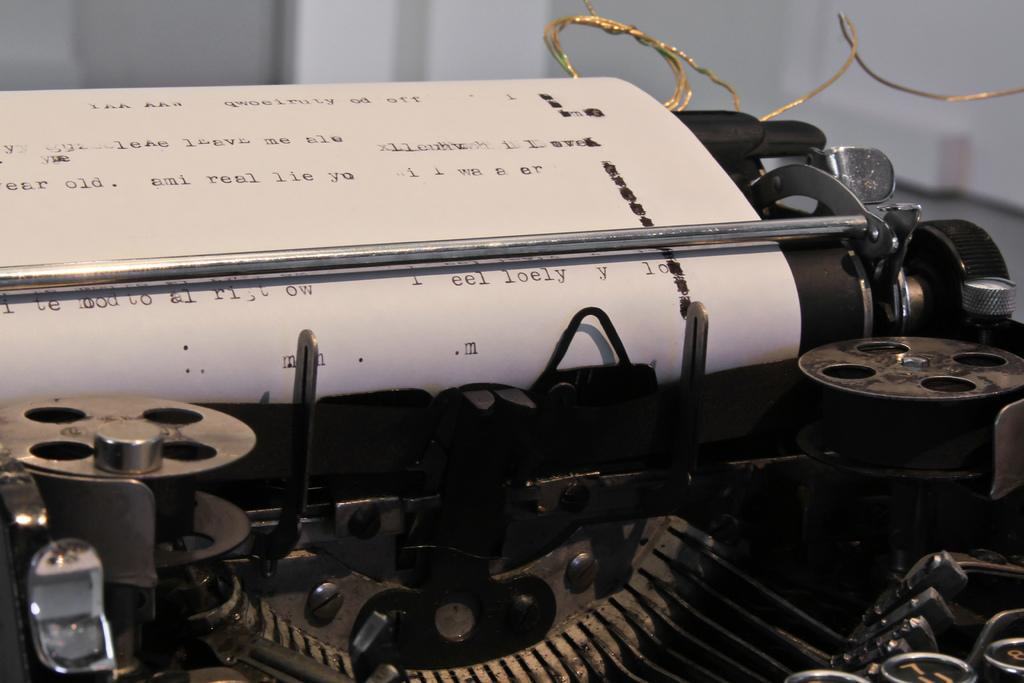What is the main object in the image? There is a typewriter in the image. What is located on the left side of the image? There is a paper on the left side of the image. What can be seen on the paper? There is text on the paper. How would you describe the background of the image? The background of the image is blurry. What type of pleasure can be seen in the image? There is no indication of pleasure in the image; it features a typewriter and paper with text. Can you see a match being struck in the image? There is no match or any indication of a match being struck in the image. 